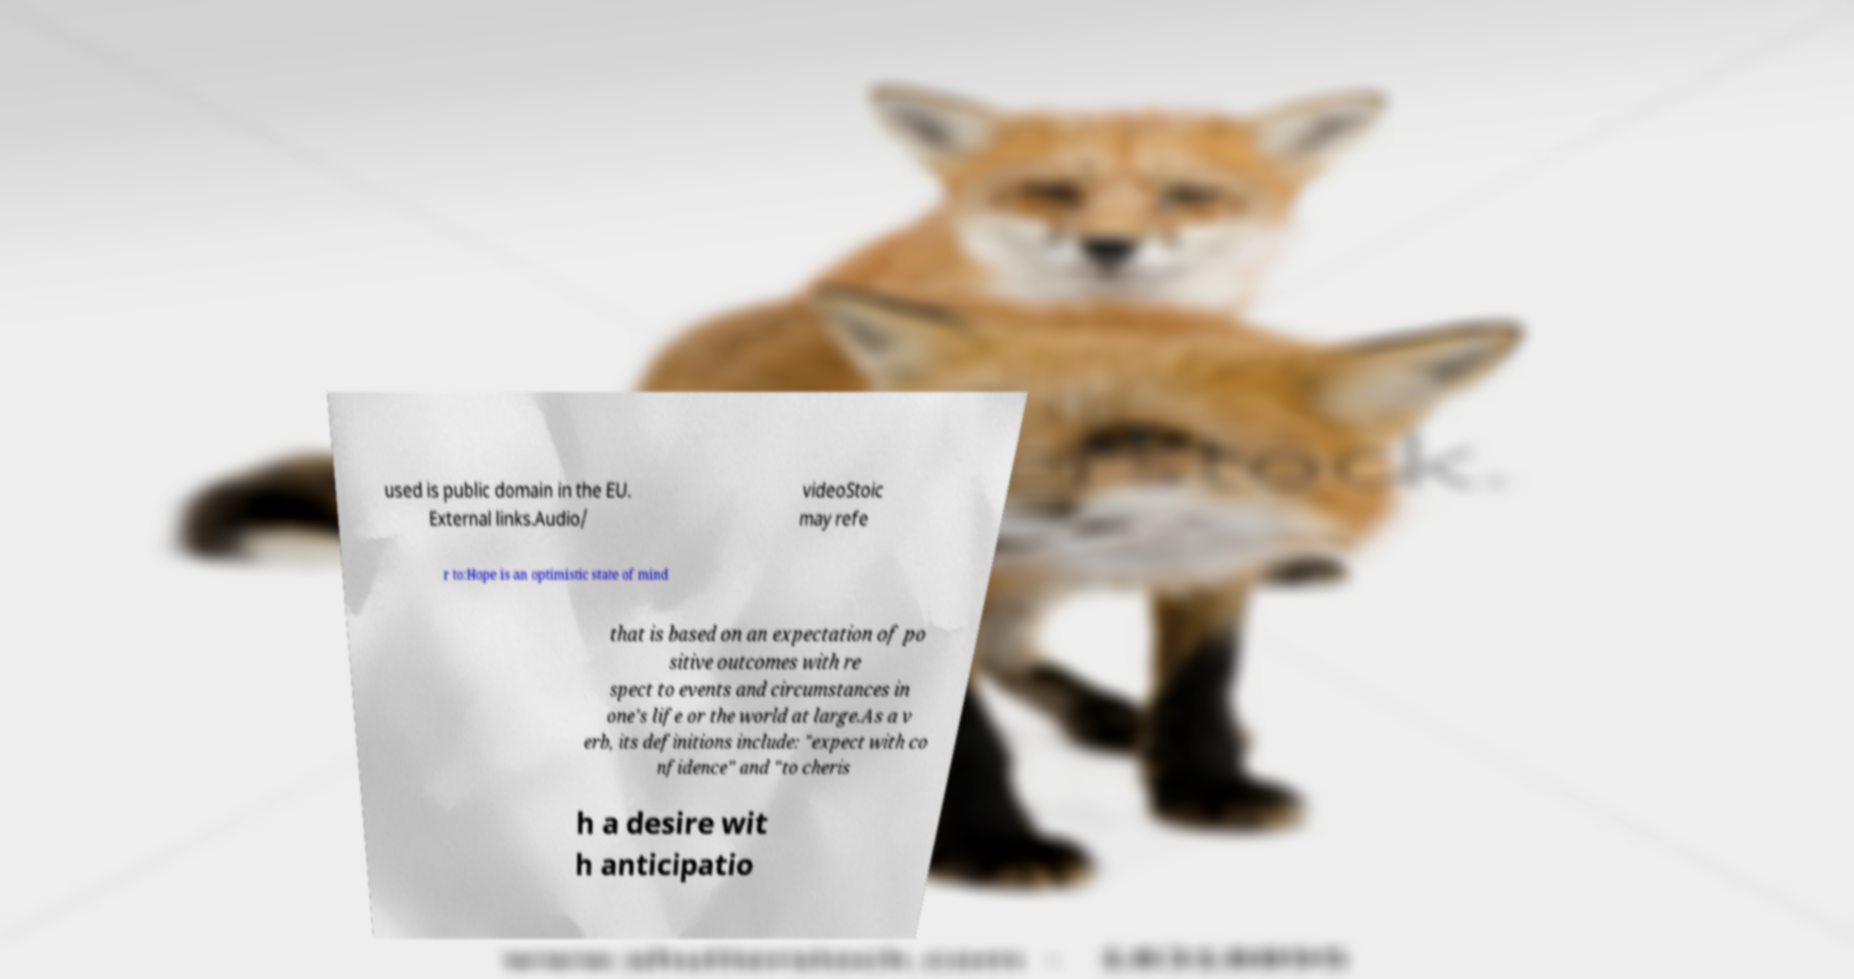I need the written content from this picture converted into text. Can you do that? used is public domain in the EU. External links.Audio/ videoStoic may refe r to:Hope is an optimistic state of mind that is based on an expectation of po sitive outcomes with re spect to events and circumstances in one's life or the world at large.As a v erb, its definitions include: "expect with co nfidence" and "to cheris h a desire wit h anticipatio 